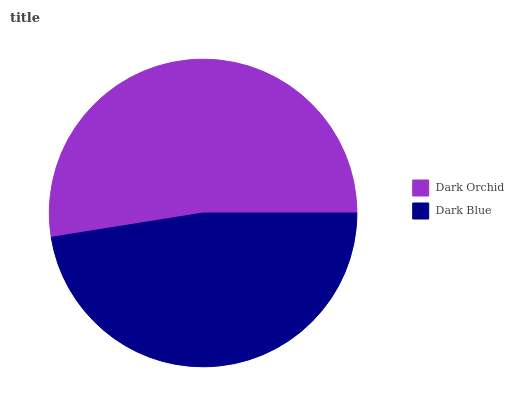Is Dark Blue the minimum?
Answer yes or no. Yes. Is Dark Orchid the maximum?
Answer yes or no. Yes. Is Dark Blue the maximum?
Answer yes or no. No. Is Dark Orchid greater than Dark Blue?
Answer yes or no. Yes. Is Dark Blue less than Dark Orchid?
Answer yes or no. Yes. Is Dark Blue greater than Dark Orchid?
Answer yes or no. No. Is Dark Orchid less than Dark Blue?
Answer yes or no. No. Is Dark Orchid the high median?
Answer yes or no. Yes. Is Dark Blue the low median?
Answer yes or no. Yes. Is Dark Blue the high median?
Answer yes or no. No. Is Dark Orchid the low median?
Answer yes or no. No. 